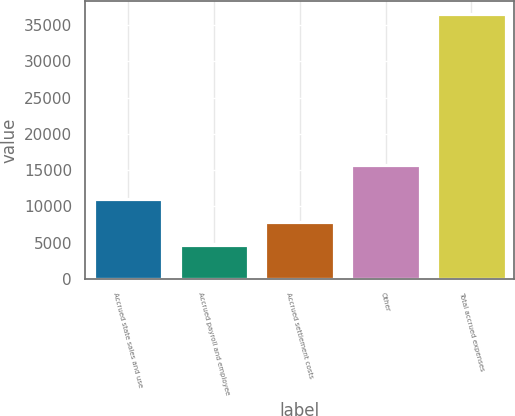Convert chart to OTSL. <chart><loc_0><loc_0><loc_500><loc_500><bar_chart><fcel>Accrued state sales and use<fcel>Accrued payroll and employee<fcel>Accrued settlement costs<fcel>Other<fcel>Total accrued expenses<nl><fcel>10978.8<fcel>4607<fcel>7792.9<fcel>15658<fcel>36466<nl></chart> 